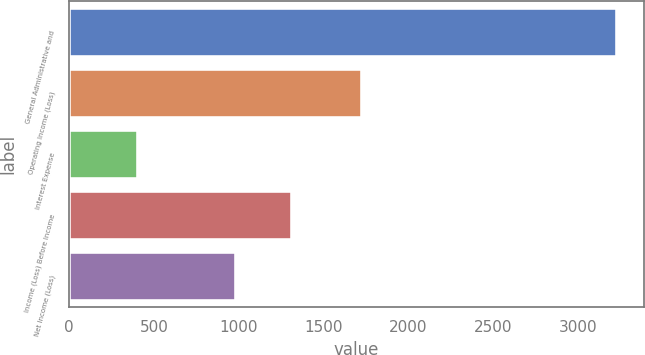Convert chart to OTSL. <chart><loc_0><loc_0><loc_500><loc_500><bar_chart><fcel>General Administrative and<fcel>Operating Income (Loss)<fcel>Interest Expense<fcel>Income (Loss) Before Income<fcel>Net Income (Loss)<nl><fcel>3231<fcel>1728<fcel>406<fcel>1312<fcel>983<nl></chart> 